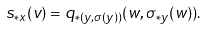Convert formula to latex. <formula><loc_0><loc_0><loc_500><loc_500>s _ { * x } ( v ) = q _ { * ( y , \sigma ( y ) ) } ( w , \sigma _ { * y } ( w ) ) .</formula> 